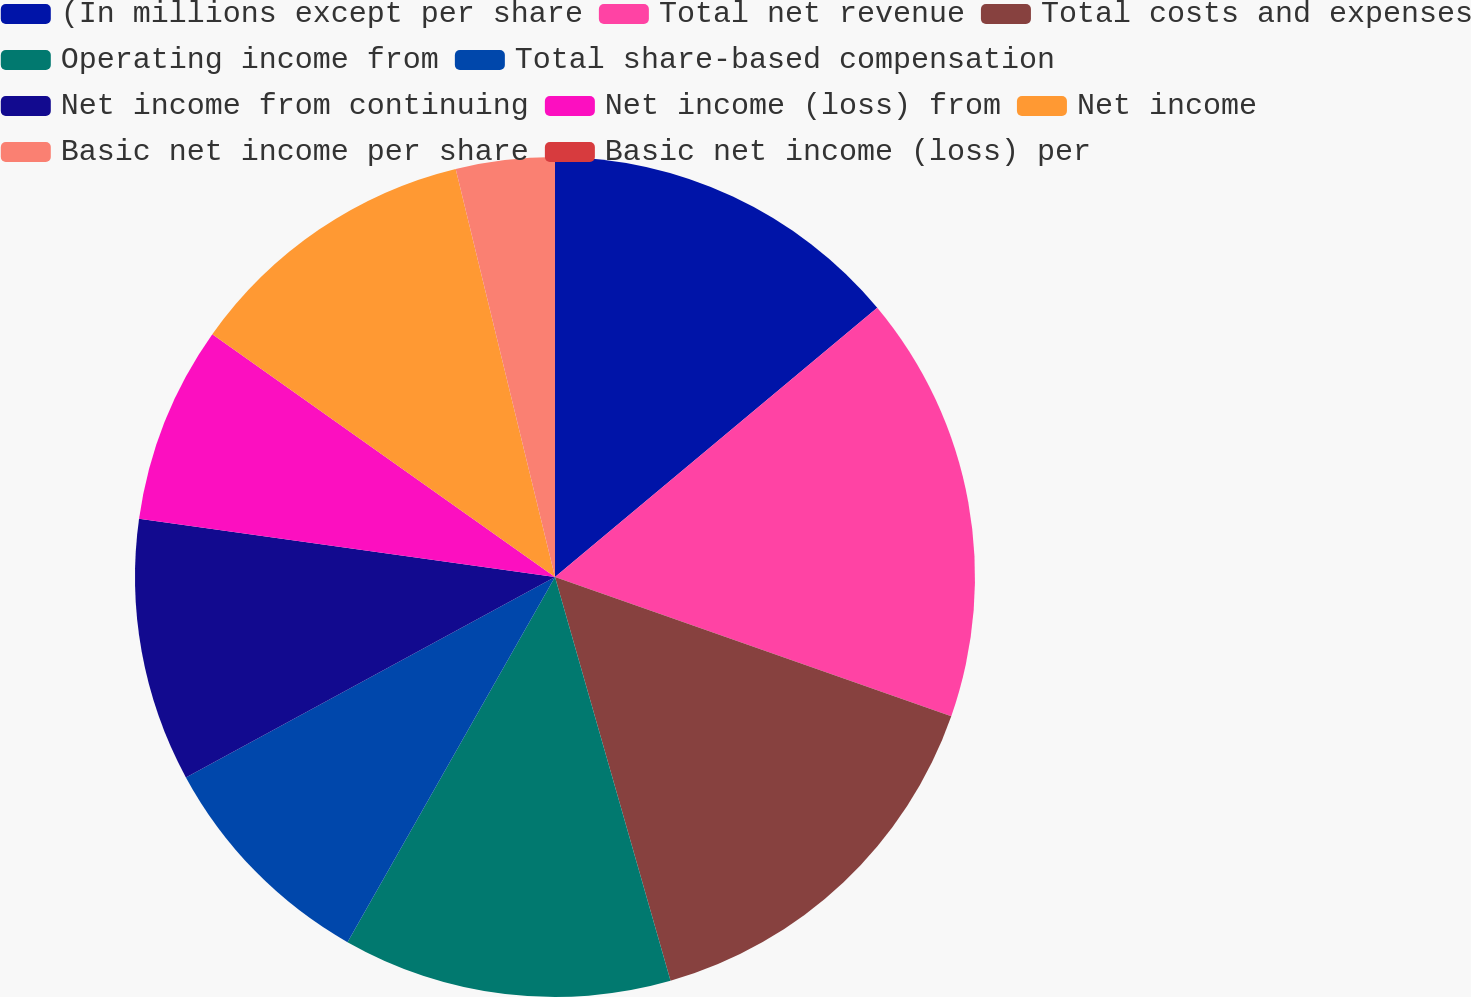<chart> <loc_0><loc_0><loc_500><loc_500><pie_chart><fcel>(In millions except per share<fcel>Total net revenue<fcel>Total costs and expenses<fcel>Operating income from<fcel>Total share-based compensation<fcel>Net income from continuing<fcel>Net income (loss) from<fcel>Net income<fcel>Basic net income per share<fcel>Basic net income (loss) per<nl><fcel>13.92%<fcel>16.46%<fcel>15.19%<fcel>12.66%<fcel>8.86%<fcel>10.13%<fcel>7.6%<fcel>11.39%<fcel>3.8%<fcel>0.0%<nl></chart> 